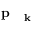Convert formula to latex. <formula><loc_0><loc_0><loc_500><loc_500>p _ { k }</formula> 